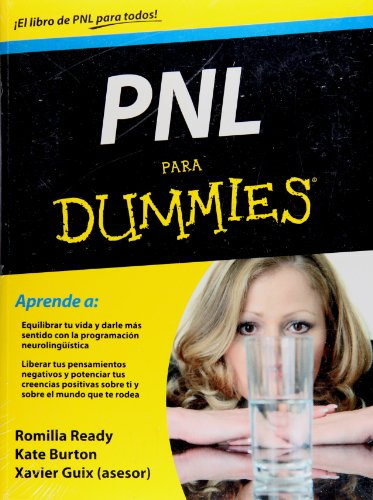What are the visual elements on the cover that indicate this book's intent? The cover features the prominent phrase 'PNL para Dummies', styled similarly to other books in the 'For Dummies' series, known for their instructive content. The image of a person peeking through a hole in the cover suggests a sense of discovery and transparency, indicating that the book aims to help readers uncover new perspectives on personal growth. 